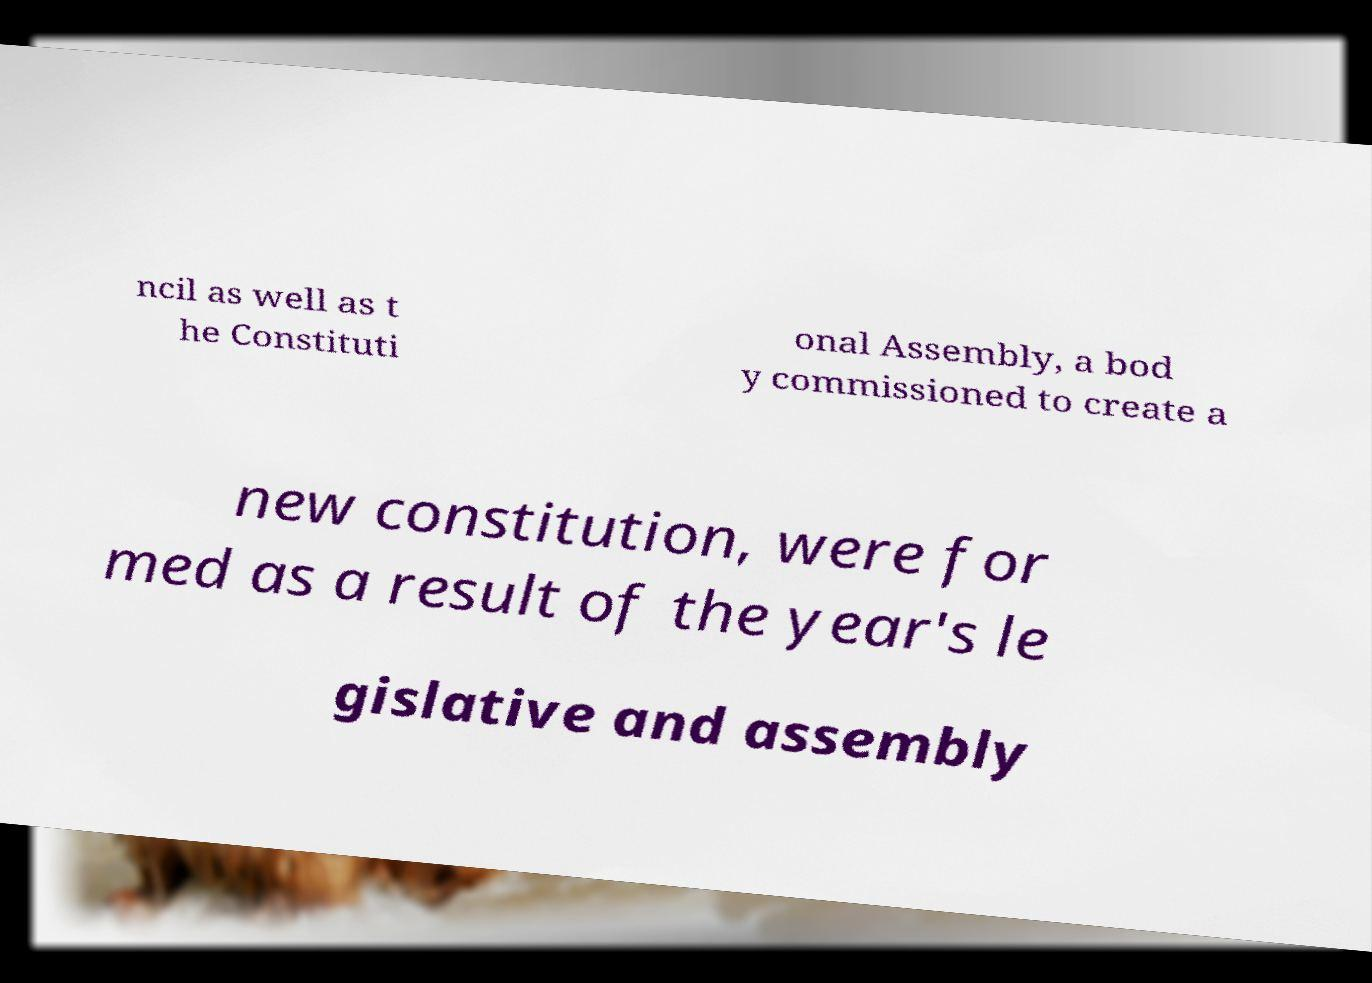I need the written content from this picture converted into text. Can you do that? ncil as well as t he Constituti onal Assembly, a bod y commissioned to create a new constitution, were for med as a result of the year's le gislative and assembly 